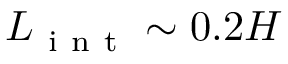<formula> <loc_0><loc_0><loc_500><loc_500>L _ { i n t } \sim 0 . 2 H</formula> 